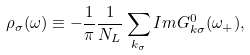Convert formula to latex. <formula><loc_0><loc_0><loc_500><loc_500>\rho _ { \sigma } ( \omega ) \equiv - \frac { 1 } { \pi } \frac { 1 } { N _ { L } } \sum _ { { k } _ { \sigma } } I m G ^ { 0 } _ { { k } \sigma } ( \omega _ { + } ) ,</formula> 